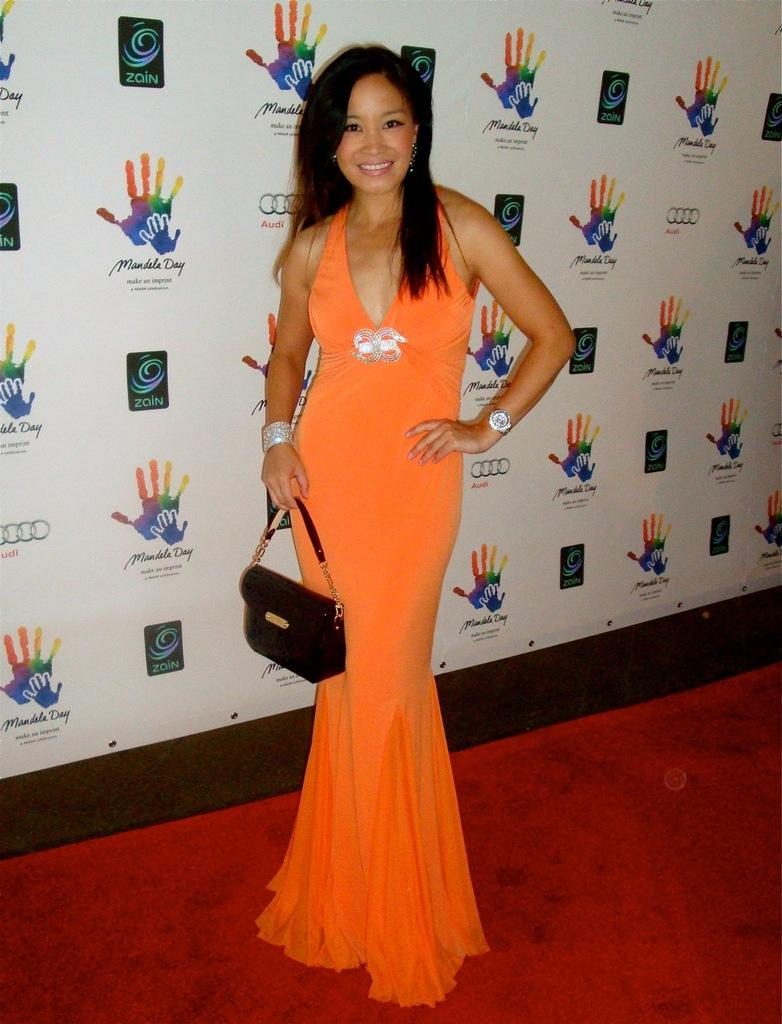Who is present in the image? There is a woman in the image. What is the woman doing in the image? The woman is standing on the floor and smiling. What is the woman holding in the image? The woman is holding a bag with her hand. What can be seen in the background of the image? There is a hoarding in the background of the image. What type of meal is the woman eating in the image? There is no meal present in the image; the woman is holding a bag and standing on the floor. 